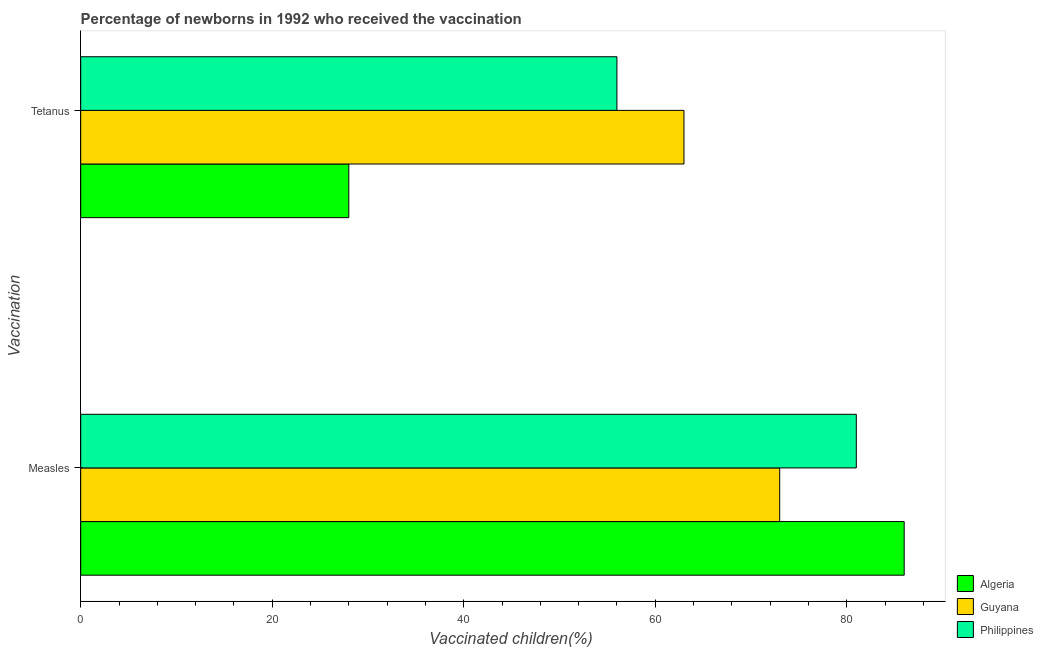How many groups of bars are there?
Your answer should be compact. 2. What is the label of the 2nd group of bars from the top?
Your answer should be very brief. Measles. What is the percentage of newborns who received vaccination for tetanus in Algeria?
Keep it short and to the point. 28. Across all countries, what is the maximum percentage of newborns who received vaccination for tetanus?
Offer a terse response. 63. Across all countries, what is the minimum percentage of newborns who received vaccination for tetanus?
Provide a short and direct response. 28. In which country was the percentage of newborns who received vaccination for measles maximum?
Your response must be concise. Algeria. In which country was the percentage of newborns who received vaccination for measles minimum?
Your response must be concise. Guyana. What is the total percentage of newborns who received vaccination for tetanus in the graph?
Provide a succinct answer. 147. What is the difference between the percentage of newborns who received vaccination for tetanus in Philippines and that in Algeria?
Make the answer very short. 28. What is the difference between the percentage of newborns who received vaccination for tetanus in Guyana and the percentage of newborns who received vaccination for measles in Philippines?
Your answer should be very brief. -18. What is the average percentage of newborns who received vaccination for measles per country?
Keep it short and to the point. 80. What is the difference between the percentage of newborns who received vaccination for tetanus and percentage of newborns who received vaccination for measles in Philippines?
Offer a terse response. -25. What does the 1st bar from the top in Tetanus represents?
Keep it short and to the point. Philippines. What does the 2nd bar from the bottom in Measles represents?
Provide a short and direct response. Guyana. How many bars are there?
Provide a short and direct response. 6. Are all the bars in the graph horizontal?
Your response must be concise. Yes. How many countries are there in the graph?
Your answer should be very brief. 3. Does the graph contain any zero values?
Keep it short and to the point. No. Does the graph contain grids?
Your answer should be compact. No. Where does the legend appear in the graph?
Your answer should be compact. Bottom right. How many legend labels are there?
Your response must be concise. 3. How are the legend labels stacked?
Ensure brevity in your answer.  Vertical. What is the title of the graph?
Offer a terse response. Percentage of newborns in 1992 who received the vaccination. What is the label or title of the X-axis?
Give a very brief answer. Vaccinated children(%)
. What is the label or title of the Y-axis?
Provide a short and direct response. Vaccination. What is the Vaccinated children(%)
 in Algeria in Measles?
Offer a very short reply. 86. What is the Vaccinated children(%)
 of Philippines in Measles?
Offer a terse response. 81. What is the Vaccinated children(%)
 in Guyana in Tetanus?
Your response must be concise. 63. What is the Vaccinated children(%)
 of Philippines in Tetanus?
Your answer should be very brief. 56. Across all Vaccination, what is the maximum Vaccinated children(%)
 in Guyana?
Your response must be concise. 73. Across all Vaccination, what is the maximum Vaccinated children(%)
 in Philippines?
Keep it short and to the point. 81. Across all Vaccination, what is the minimum Vaccinated children(%)
 of Algeria?
Your answer should be compact. 28. Across all Vaccination, what is the minimum Vaccinated children(%)
 of Philippines?
Your answer should be compact. 56. What is the total Vaccinated children(%)
 of Algeria in the graph?
Give a very brief answer. 114. What is the total Vaccinated children(%)
 of Guyana in the graph?
Make the answer very short. 136. What is the total Vaccinated children(%)
 in Philippines in the graph?
Offer a terse response. 137. What is the difference between the Vaccinated children(%)
 in Algeria in Measles and the Vaccinated children(%)
 in Guyana in Tetanus?
Provide a succinct answer. 23. What is the difference between the Vaccinated children(%)
 in Guyana in Measles and the Vaccinated children(%)
 in Philippines in Tetanus?
Provide a succinct answer. 17. What is the average Vaccinated children(%)
 of Philippines per Vaccination?
Provide a short and direct response. 68.5. What is the difference between the Vaccinated children(%)
 of Algeria and Vaccinated children(%)
 of Guyana in Tetanus?
Your response must be concise. -35. What is the difference between the Vaccinated children(%)
 in Guyana and Vaccinated children(%)
 in Philippines in Tetanus?
Keep it short and to the point. 7. What is the ratio of the Vaccinated children(%)
 of Algeria in Measles to that in Tetanus?
Ensure brevity in your answer.  3.07. What is the ratio of the Vaccinated children(%)
 in Guyana in Measles to that in Tetanus?
Give a very brief answer. 1.16. What is the ratio of the Vaccinated children(%)
 of Philippines in Measles to that in Tetanus?
Keep it short and to the point. 1.45. What is the difference between the highest and the second highest Vaccinated children(%)
 of Guyana?
Your answer should be very brief. 10. What is the difference between the highest and the second highest Vaccinated children(%)
 in Philippines?
Your response must be concise. 25. What is the difference between the highest and the lowest Vaccinated children(%)
 in Guyana?
Ensure brevity in your answer.  10. 